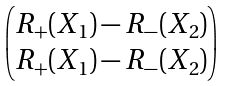<formula> <loc_0><loc_0><loc_500><loc_500>\begin{pmatrix} R _ { + } ( X _ { 1 } ) - R _ { - } ( X _ { 2 } ) \\ R _ { + } ( X _ { 1 } ) - R _ { - } ( X _ { 2 } ) \\ \end{pmatrix}</formula> 